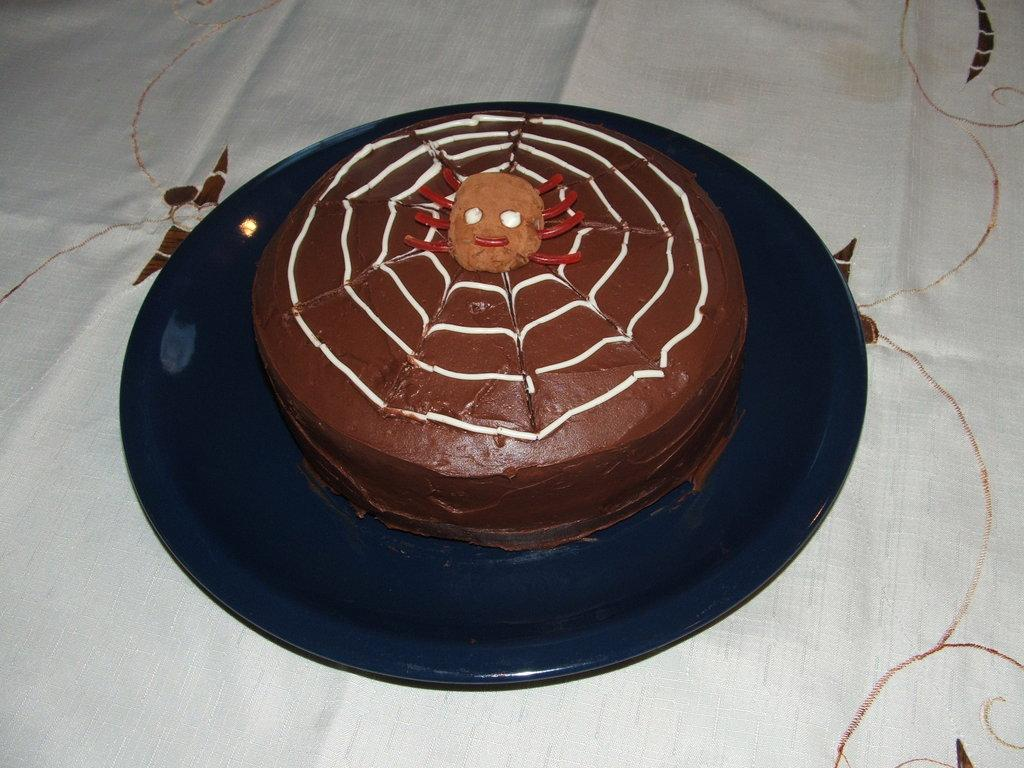What is the main subject of the image? There is a cake in the image. What is the cake placed on? The cake is on a blue color plate. Where is the plate located? The plate is on a table. What is covering the table? The table is covered with a white cloth. Can you tell me how many cactus plants are on the table in the image? There are no cactus plants present in the image; the table is covered with a white cloth and has a cake on a blue plate. 